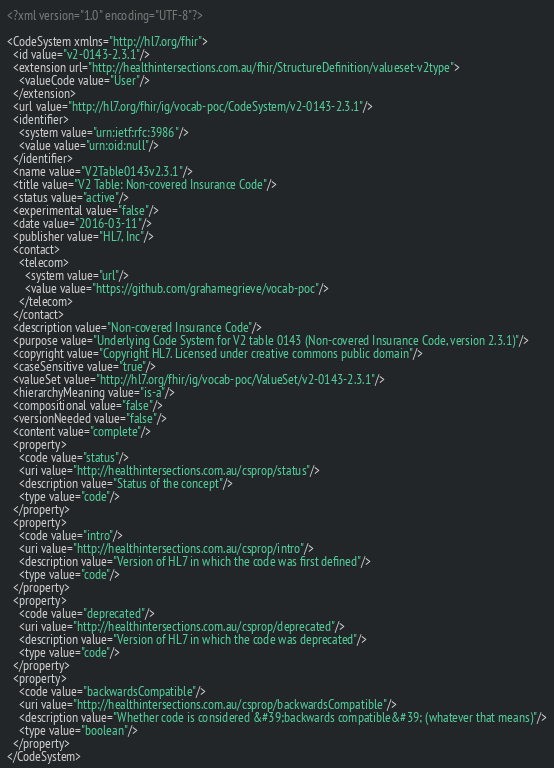<code> <loc_0><loc_0><loc_500><loc_500><_XML_><?xml version="1.0" encoding="UTF-8"?>

<CodeSystem xmlns="http://hl7.org/fhir">
  <id value="v2-0143-2.3.1"/>
  <extension url="http://healthintersections.com.au/fhir/StructureDefinition/valueset-v2type">
    <valueCode value="User"/>
  </extension>
  <url value="http://hl7.org/fhir/ig/vocab-poc/CodeSystem/v2-0143-2.3.1"/>
  <identifier>
    <system value="urn:ietf:rfc:3986"/>
    <value value="urn:oid:null"/>
  </identifier>
  <name value="V2Table0143v2.3.1"/>
  <title value="V2 Table: Non-covered Insurance Code"/>
  <status value="active"/>
  <experimental value="false"/>
  <date value="2016-03-11"/>
  <publisher value="HL7, Inc"/>
  <contact>
    <telecom>
      <system value="url"/>
      <value value="https://github.com/grahamegrieve/vocab-poc"/>
    </telecom>
  </contact>
  <description value="Non-covered Insurance Code"/>
  <purpose value="Underlying Code System for V2 table 0143 (Non-covered Insurance Code, version 2.3.1)"/>
  <copyright value="Copyright HL7. Licensed under creative commons public domain"/>
  <caseSensitive value="true"/>
  <valueSet value="http://hl7.org/fhir/ig/vocab-poc/ValueSet/v2-0143-2.3.1"/>
  <hierarchyMeaning value="is-a"/>
  <compositional value="false"/>
  <versionNeeded value="false"/>
  <content value="complete"/>
  <property>
    <code value="status"/>
    <uri value="http://healthintersections.com.au/csprop/status"/>
    <description value="Status of the concept"/>
    <type value="code"/>
  </property>
  <property>
    <code value="intro"/>
    <uri value="http://healthintersections.com.au/csprop/intro"/>
    <description value="Version of HL7 in which the code was first defined"/>
    <type value="code"/>
  </property>
  <property>
    <code value="deprecated"/>
    <uri value="http://healthintersections.com.au/csprop/deprecated"/>
    <description value="Version of HL7 in which the code was deprecated"/>
    <type value="code"/>
  </property>
  <property>
    <code value="backwardsCompatible"/>
    <uri value="http://healthintersections.com.au/csprop/backwardsCompatible"/>
    <description value="Whether code is considered &#39;backwards compatible&#39; (whatever that means)"/>
    <type value="boolean"/>
  </property>
</CodeSystem></code> 